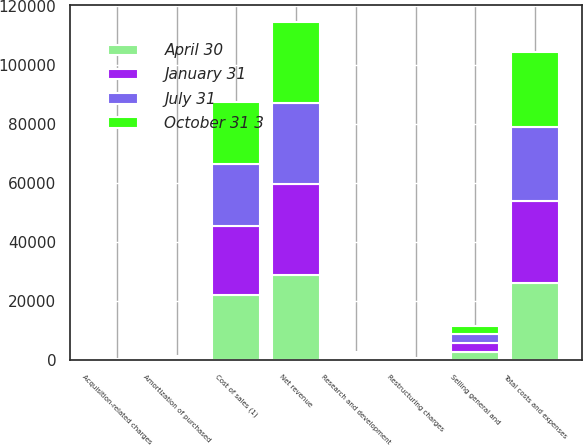<chart> <loc_0><loc_0><loc_500><loc_500><stacked_bar_chart><ecel><fcel>Net revenue<fcel>Cost of sales (1)<fcel>Research and development<fcel>Selling general and<fcel>Amortization of purchased<fcel>Restructuring charges<fcel>Acquisition-related charges<fcel>Total costs and expenses<nl><fcel>April 30<fcel>28807<fcel>22073<fcel>732<fcel>2893<fcel>412<fcel>146<fcel>48<fcel>26310<nl><fcel>July 31<fcel>27383<fcel>20945<fcel>716<fcel>2880<fcel>380<fcel>94<fcel>75<fcel>25090<nl><fcel>October 31 3<fcel>27585<fcel>21031<fcel>667<fcel>2874<fcel>379<fcel>362<fcel>59<fcel>25372<nl><fcel>January 31<fcel>30777<fcel>23475<fcel>704<fcel>2966<fcel>400<fcel>38<fcel>60<fcel>27644<nl></chart> 